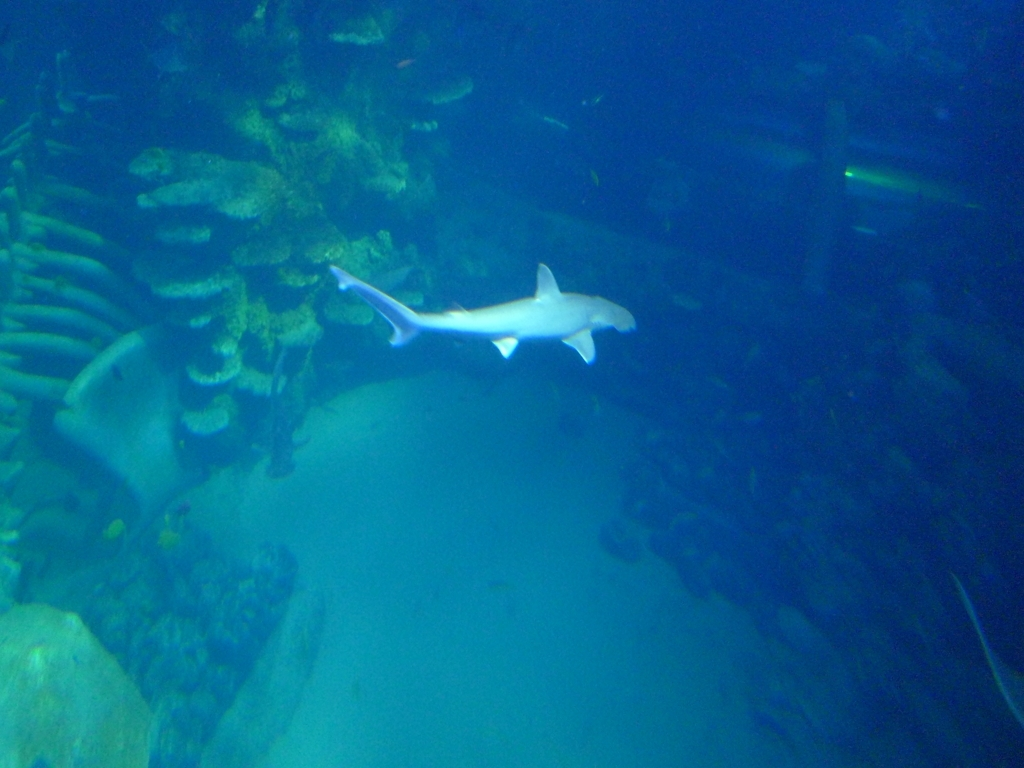What species of shark is shown in the image, and what can you tell me about it? The image quality makes it difficult to determine the exact species with certainty, but based on the shape and the visible fins, it could be a type of reef shark. These sharks are generally found in warm waters around coral reefs where they play an important role in the ecosystem by helping to maintain the balance of marine life. 